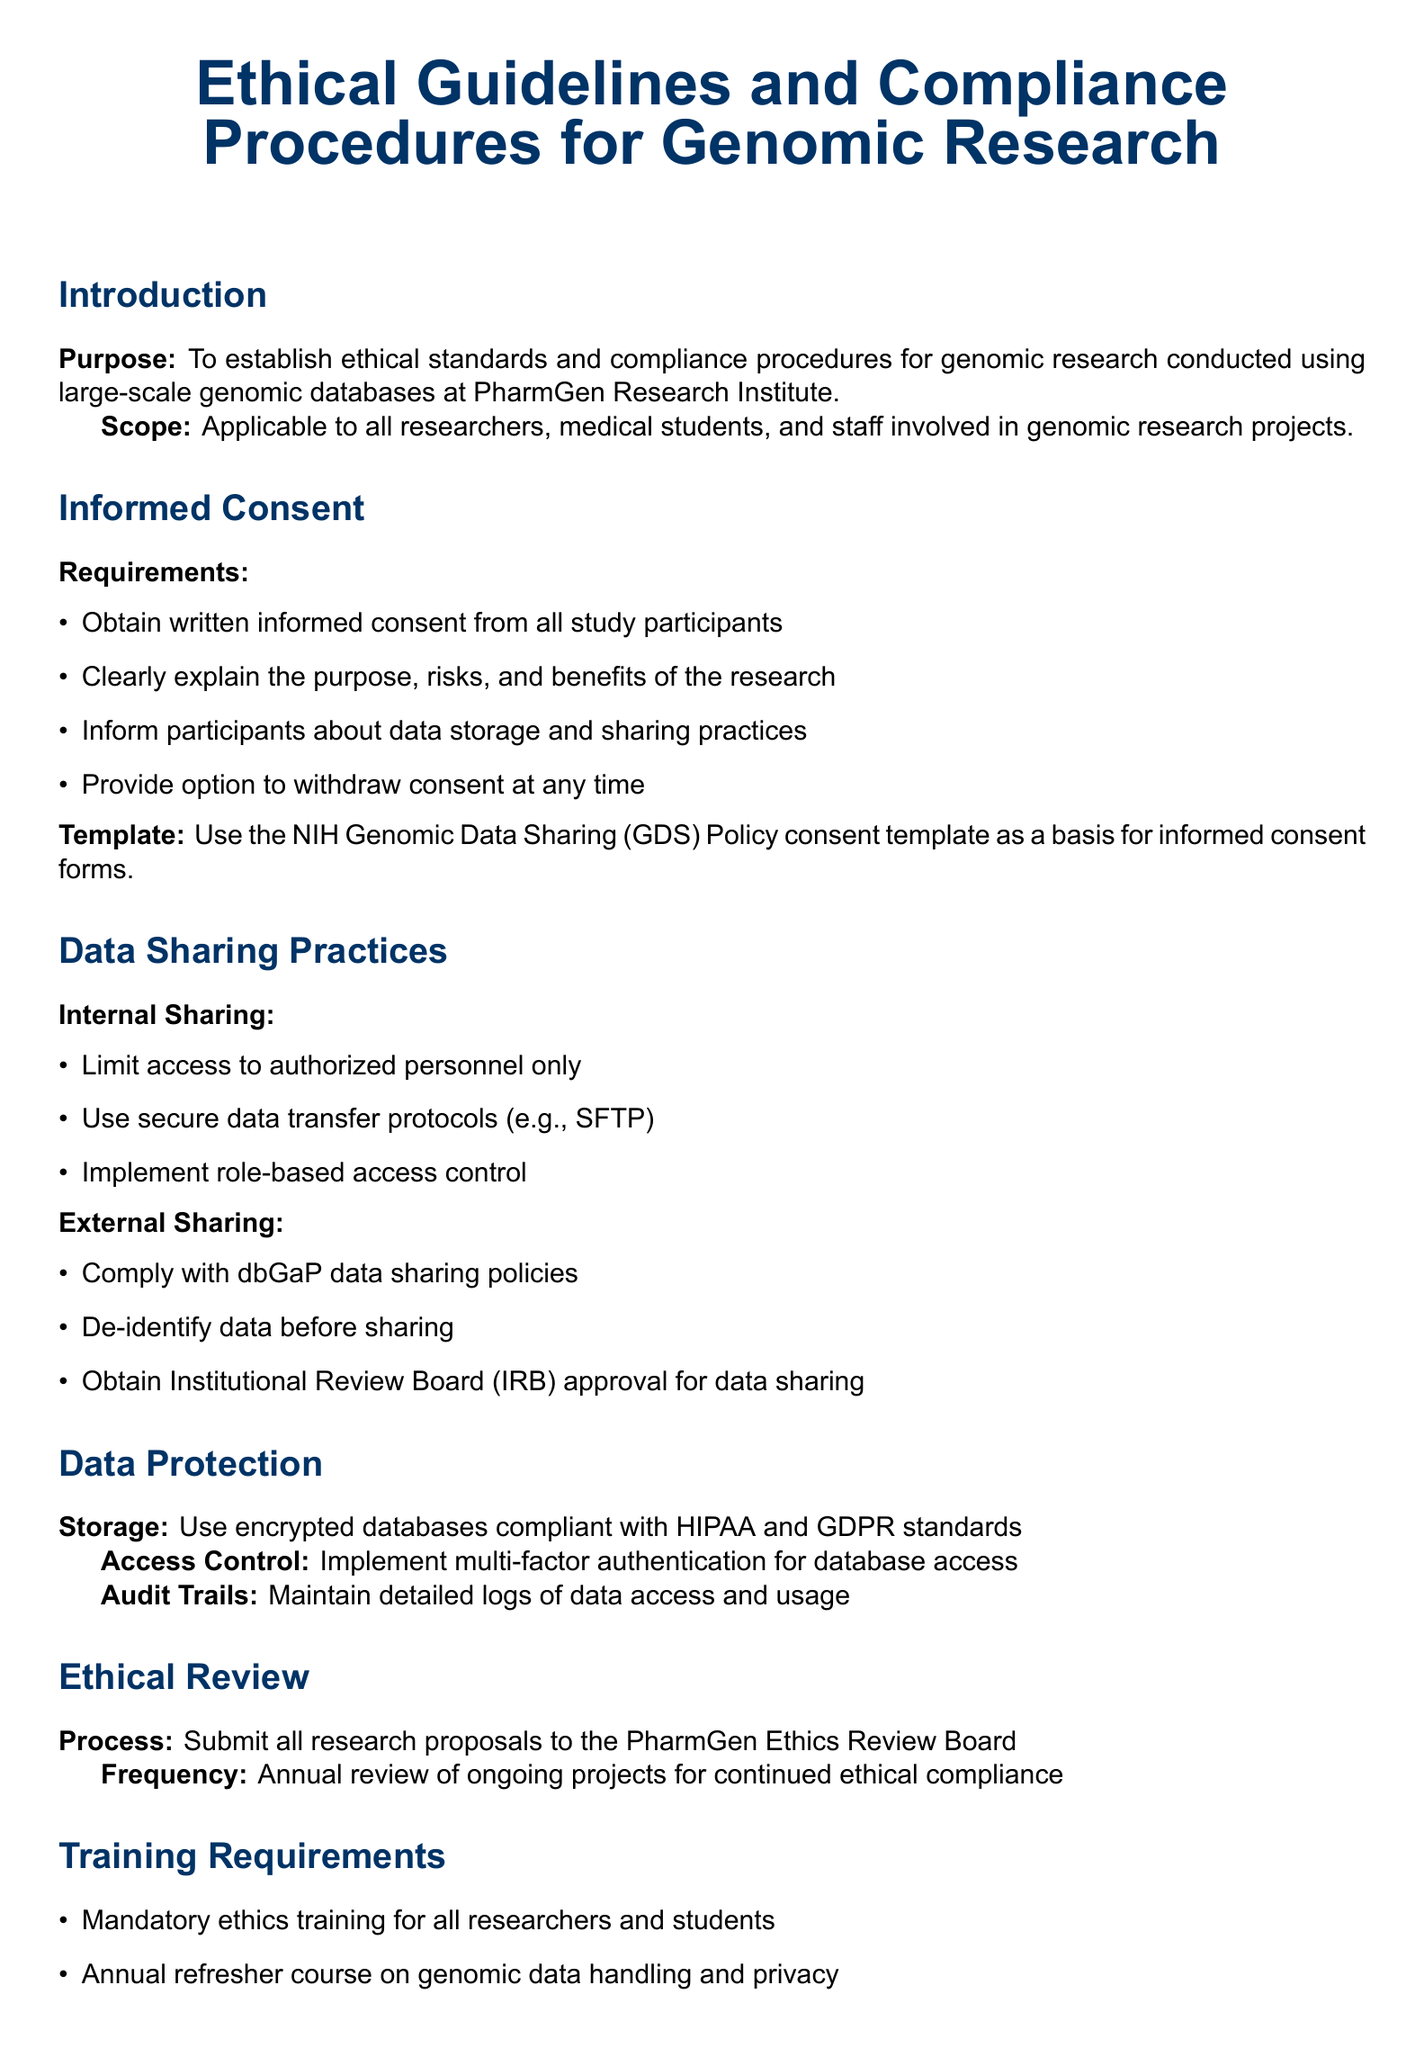What is the purpose of the document? The document establishes ethical standards and compliance procedures for genomic research conducted using large-scale genomic databases at PharmGen Research Institute.
Answer: To establish ethical standards and compliance procedures for genomic research What must be obtained from all study participants? The document specifies requirements for informed consent which must be obtained from participants.
Answer: Written informed consent What template should be used for informed consent forms? The document mentions using a specific template for informed consent forms.
Answer: NIH Genomic Data Sharing (GDS) Policy consent template What type of access control is implemented for data protection? The document details specific access control measures for database access.
Answer: Multi-factor authentication How often should ongoing projects be reviewed for ethical compliance? The document states the frequency of reviewing ongoing projects submitted to the Ethics Review Board.
Answer: Annually What is one of the mandatory training requirements mentioned? The document outlines specific training requirements for researchers and students involved in genomic research.
Answer: Mandatory ethics training Which hotline is mentioned for reporting ethical concerns? The document specifies a procedure for reporting ethical concerns or violations.
Answer: PharmGen Ethics Hotline What type of audits are conducted quarterly? The document lists different compliance monitoring methods including the frequency of auditing.
Answer: Internal Audits What must be done before sharing data externally? The document explains requirements for data sharing practices with emphasis on de-identification.
Answer: De-identify data before sharing 